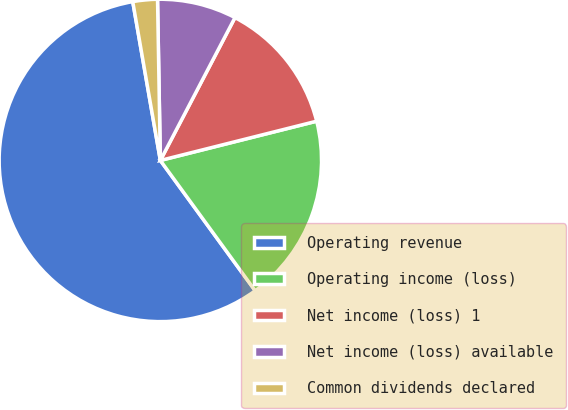Convert chart to OTSL. <chart><loc_0><loc_0><loc_500><loc_500><pie_chart><fcel>Operating revenue<fcel>Operating income (loss)<fcel>Net income (loss) 1<fcel>Net income (loss) available<fcel>Common dividends declared<nl><fcel>57.27%<fcel>18.9%<fcel>13.42%<fcel>7.94%<fcel>2.46%<nl></chart> 